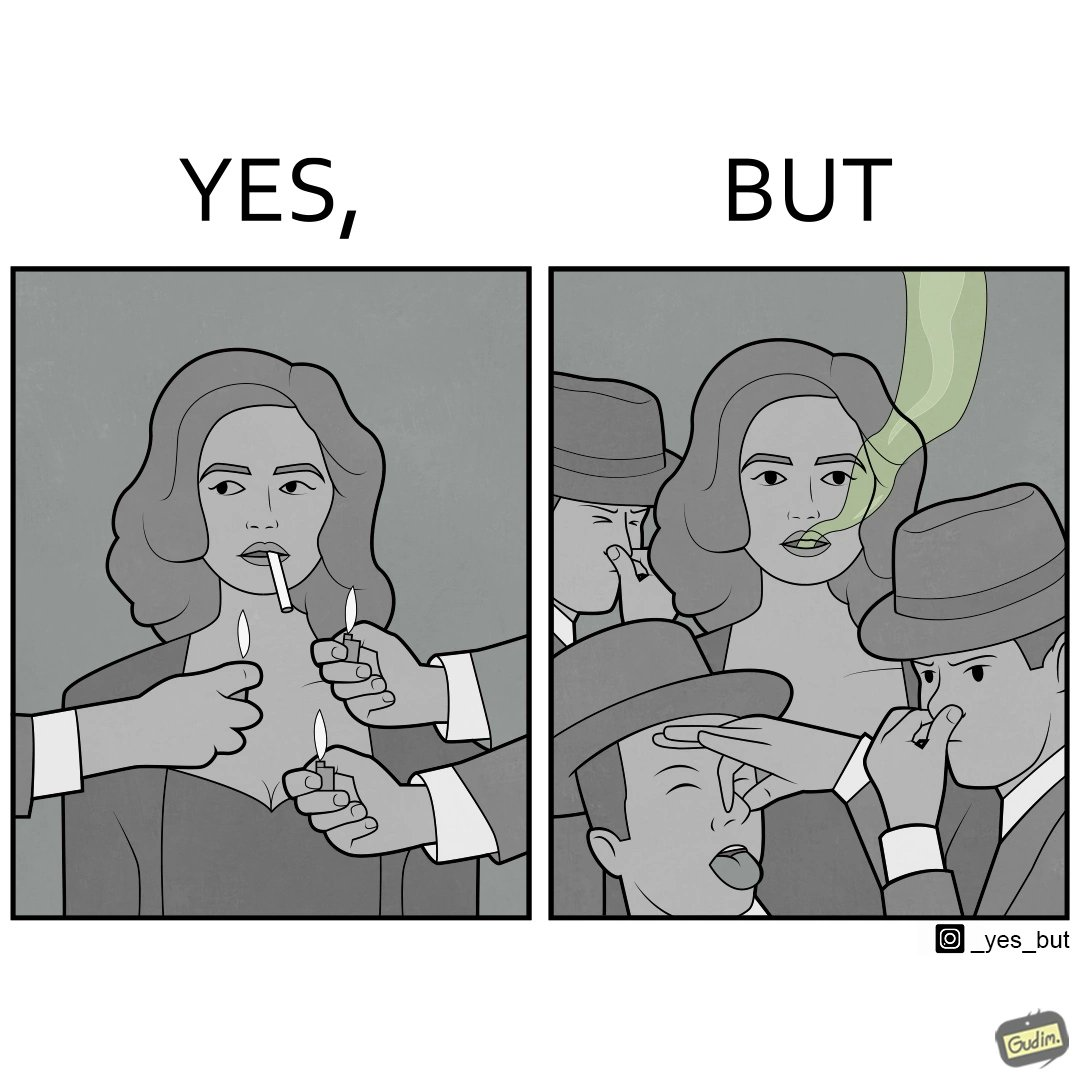Why is this image considered satirical? The image is ironical, as people seem to be holding lighters to light up a woman's cigarette at an attempt to probably  impress her, while showing that the very same people are holding their noses on account of what appears to be bad smell coming out of the woman's mouth. 